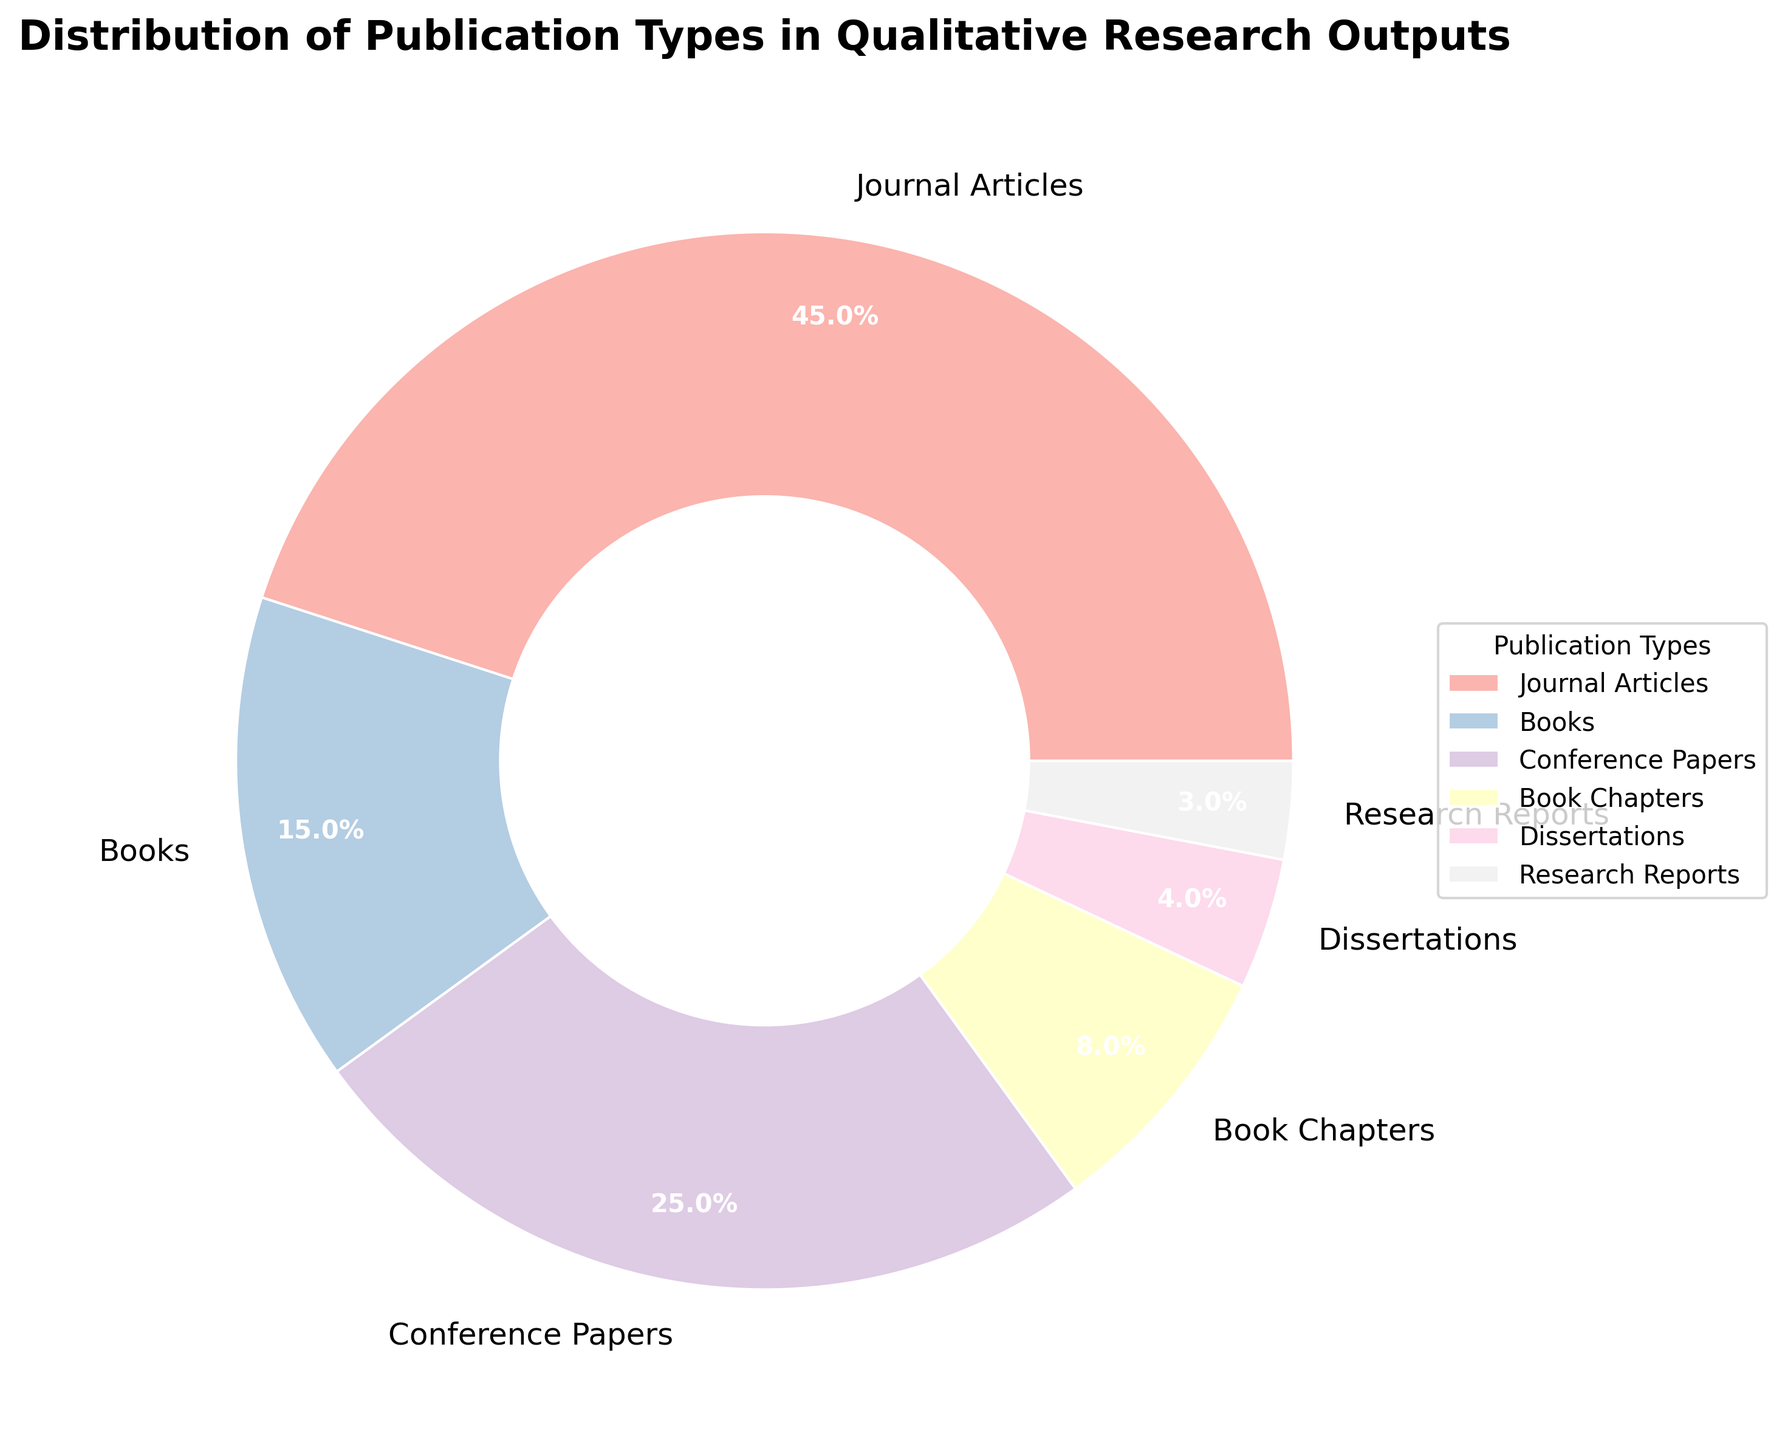Which publication type has the highest percentage? According to the chart, journal articles have the largest wedge or segment of the pie, indicating the highest percentage of qualitative research outputs. The associated percentage for journal articles is 45%.
Answer: Journal Articles What is the combined percentage of books and conference papers? The percentage of books is 15% and the percentage of conference papers is 25%. Adding these together gives 15% + 25% = 40%.
Answer: 40% How many publication types make up less than 10% each? The publication types with percentages less than 10% are book chapters (8%), dissertations (4%), and research reports (3%). This makes a total of 3 publication types.
Answer: 3 Which two publication types together account for more than half of the qualitative research outputs? Journal Articles (45%) and Conference Papers (25%) together account for 45% + 25% = 70%, which is more than half of the total.
Answer: Journal Articles and Conference Papers What is the difference in percentage points between journal articles and books? Journal Articles have 45% and Books have 15%. The difference in their percentages is 45% - 15% = 30%.
Answer: 30% Which publication type has the smallest percentage, and what is the exact value? The publication type with the smallest wedge or segment is research reports, which has a percentage of 3%.
Answer: Research Reports, 3% Do books and book chapters together have a higher percentage than conference papers alone? The percentage for books is 15% and for book chapters is 8%. Summing these gives 15% + 8% = 23%. Conference Papers alone are 25%. So, 23% is not higher than 25%.
Answer: No What is the average percentage of dissertations and research reports combined? The percentage for dissertations is 4% and for research reports is 3%. Their average is (4% + 3%)/2 = 3.5%.
Answer: 3.5% What proportion of publication types have a percentage greater than or equal to 10%? The publication types with percentages greater than or equal to 10% are Journal Articles (45%), Books (15%), and Conference Papers (25%). That's 3 out of 6 publication types, or 50%.
Answer: 50% 